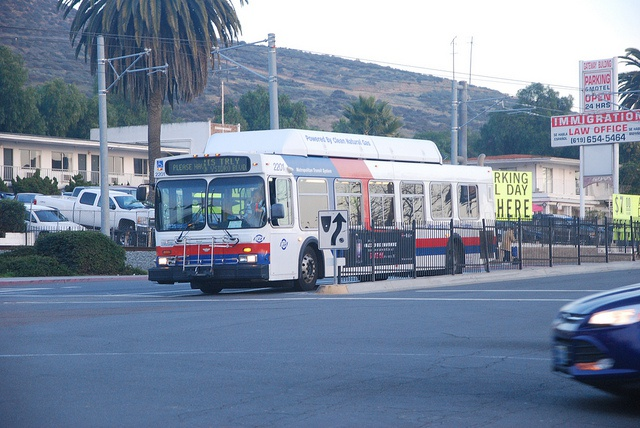Describe the objects in this image and their specific colors. I can see bus in blue, lightgray, darkgray, navy, and gray tones, car in blue, black, navy, darkblue, and lightblue tones, truck in blue, lavender, darkgray, and lightblue tones, car in blue, gray, and navy tones, and car in blue, lavender, gray, and darkgray tones in this image. 